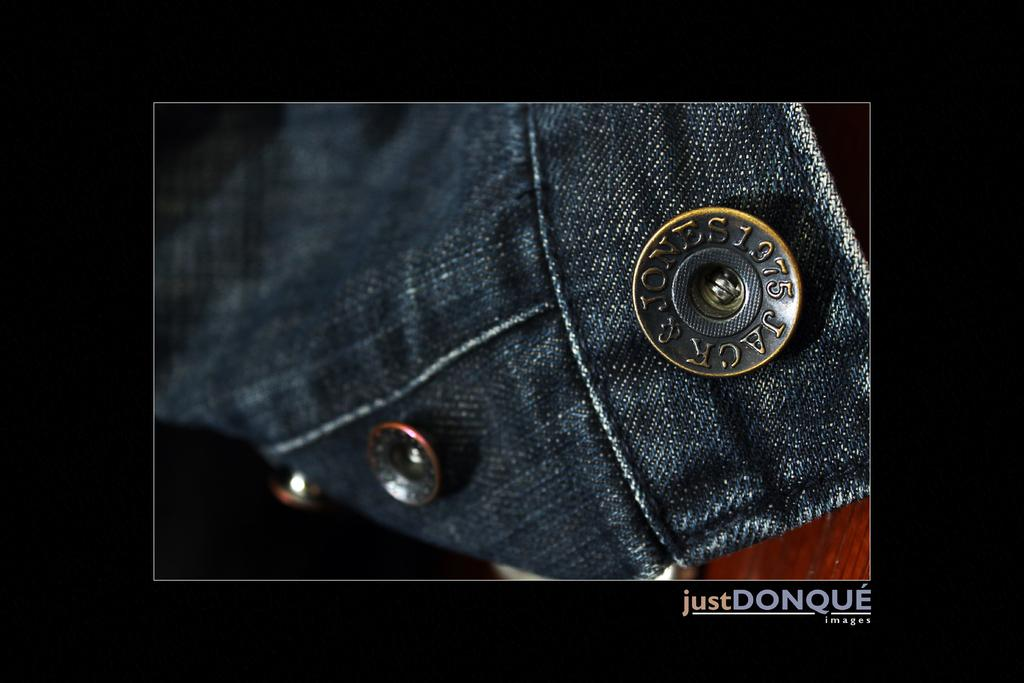What type of clothing is visible in the image? There are jeans in the image. What type of fasteners can be seen on the jeans? There are buttons in the image. What type of bread is being used to make the jeans in the image? There is no bread present in the image, and bread is not used to make jeans. 